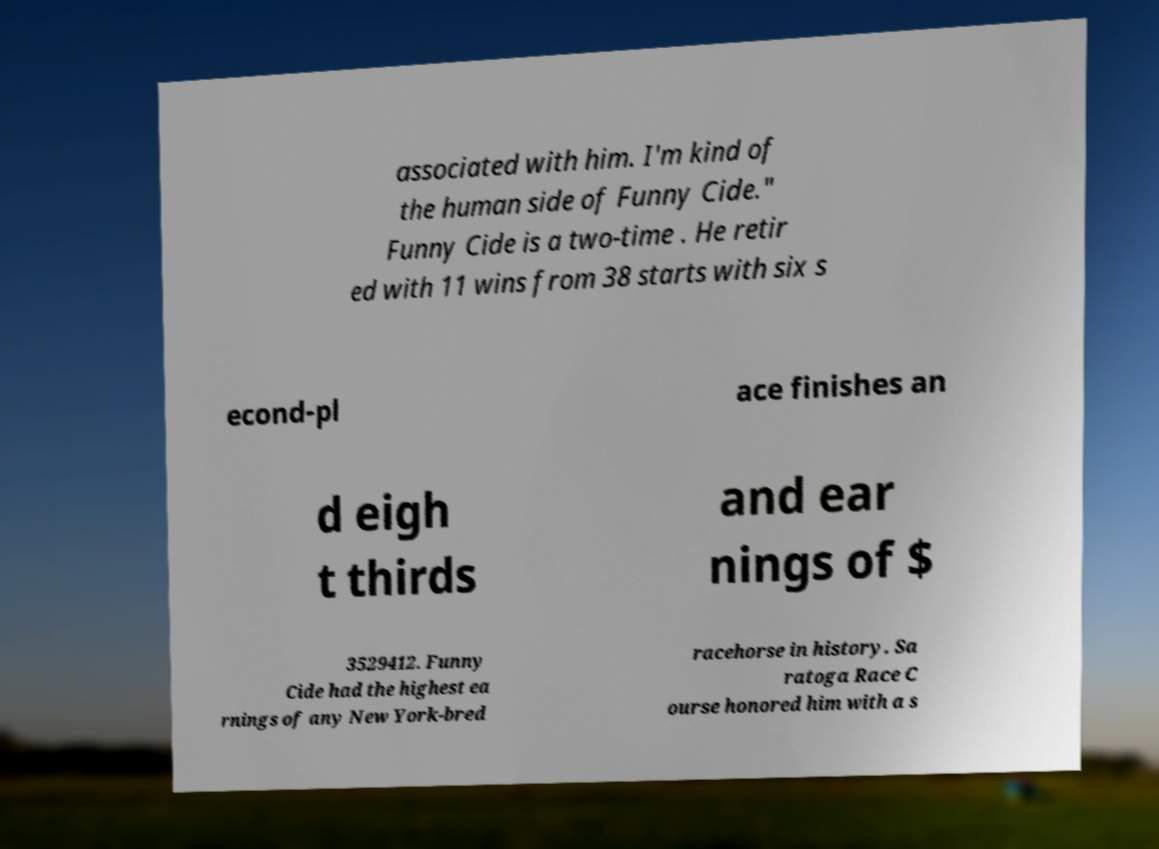Can you read and provide the text displayed in the image?This photo seems to have some interesting text. Can you extract and type it out for me? associated with him. I'm kind of the human side of Funny Cide." Funny Cide is a two-time . He retir ed with 11 wins from 38 starts with six s econd-pl ace finishes an d eigh t thirds and ear nings of $ 3529412. Funny Cide had the highest ea rnings of any New York-bred racehorse in history. Sa ratoga Race C ourse honored him with a s 